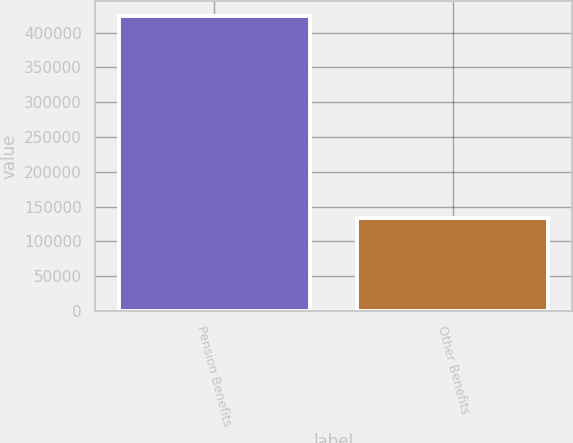Convert chart to OTSL. <chart><loc_0><loc_0><loc_500><loc_500><bar_chart><fcel>Pension Benefits<fcel>Other Benefits<nl><fcel>424519<fcel>132984<nl></chart> 